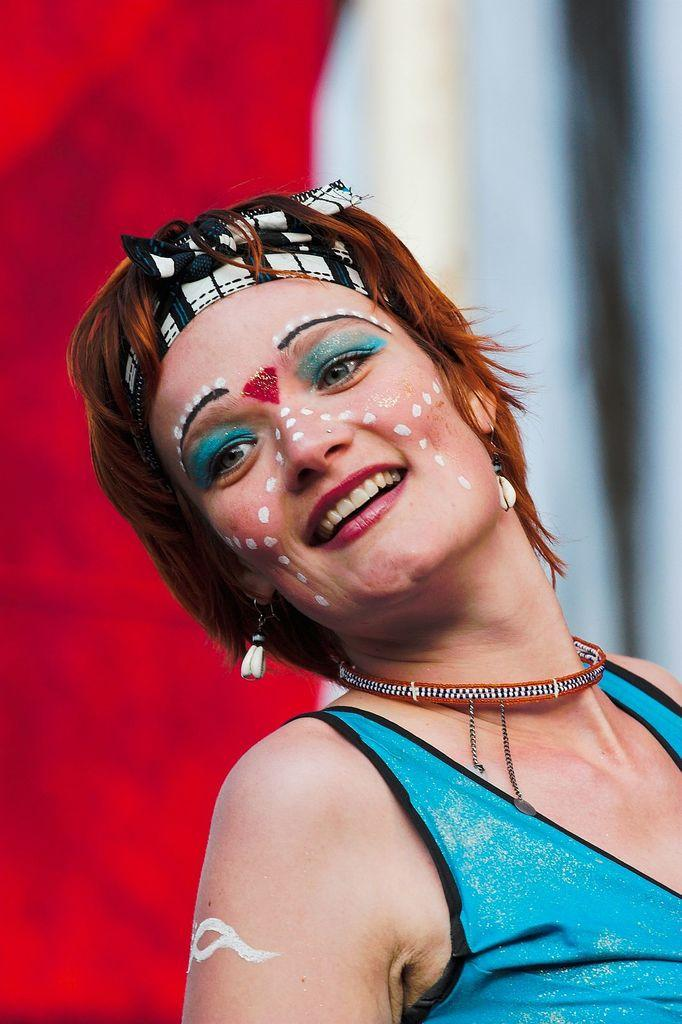Who is the main subject in the image? There is a woman in the image. What expression does the woman have? The woman is smiling. Can you describe the background of the image? The background of the image is blurry. What type of argument is the woman having with the governor in the image? There is no governor or argument present in the image; it only features a woman smiling. What kind of suit is the woman wearing in the image? The woman is not wearing a suit in the image; she is wearing a dress or other clothing. 